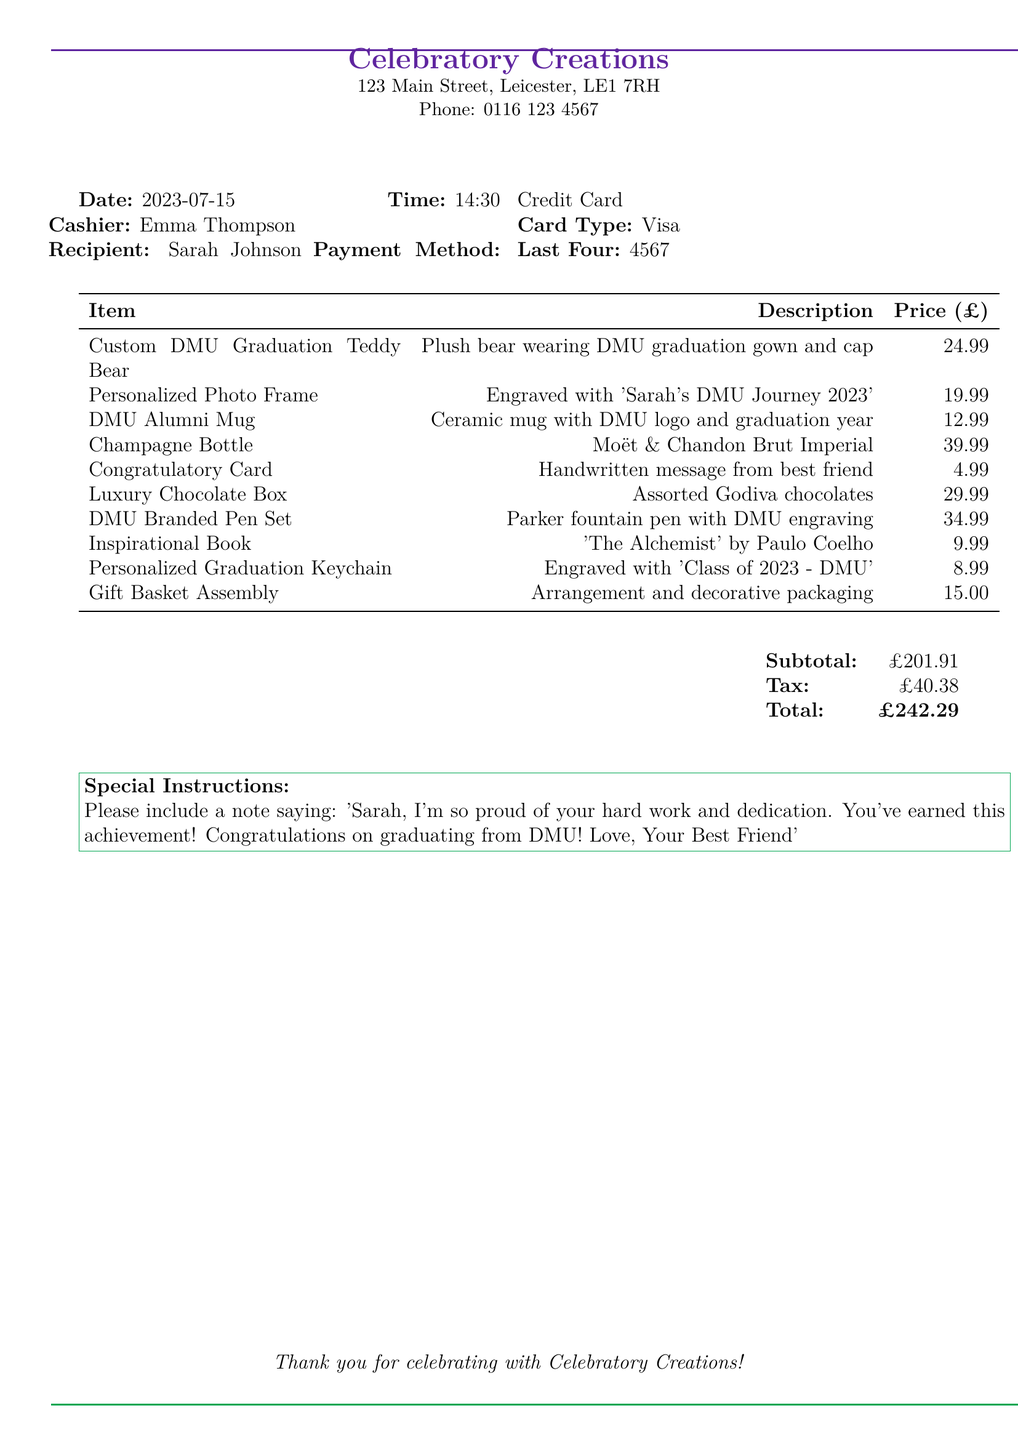What is the store name? The store name is provided at the top of the document.
Answer: Celebratory Creations What is the recipient's name? The recipient's name is listed alongside other transaction details.
Answer: Sarah Johnson What is the total amount of the transaction? The total amount is displayed at the end of the document in the summary.
Answer: £242.29 Who was the cashier for this transaction? The cashier's name is listed in the transaction details section.
Answer: Emma Thompson What is the date of the purchase? The date of the purchase is specified at the top of the document.
Answer: 2023-07-15 How many items are included in the gift basket? The number of items can be counted from the list of items in the document.
Answer: 10 What is the price of the Champagne Bottle? The price of each individual item is shown in the itemized list.
Answer: 39.99 What special instruction was included with the order? The special instruction is noted in its dedicated section near the end of the document.
Answer: Please include a note saying: 'Sarah, I'm so proud of your hard work and dedication. You've earned this achievement! Congratulations on graduating from DMU! Love, Your Best Friend' What type of card was used for payment? The type of card used is specified in the payment details section.
Answer: Visa What is the subtotal before tax? The subtotal is clearly outlined in the summary of the transaction.
Answer: £201.91 